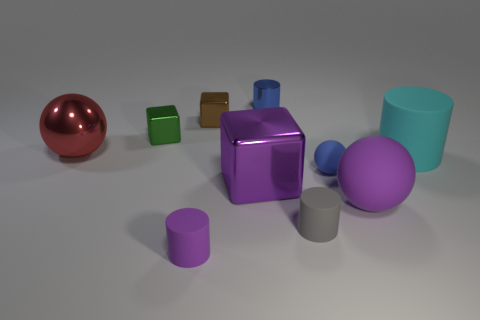Can you describe the different colors and shapes present in this image? Certainly! The image features a variety of colors including red, green, blue, purple, and teal. As for shapes, there's a sphere, cubes, a cylinder, and a rectangular prism. Do the objects seem to be made of different materials? Yes, the objects appear to have different textures and reflections that suggest they could be made of various materials such as metal, plastic, or perhaps even glass. 